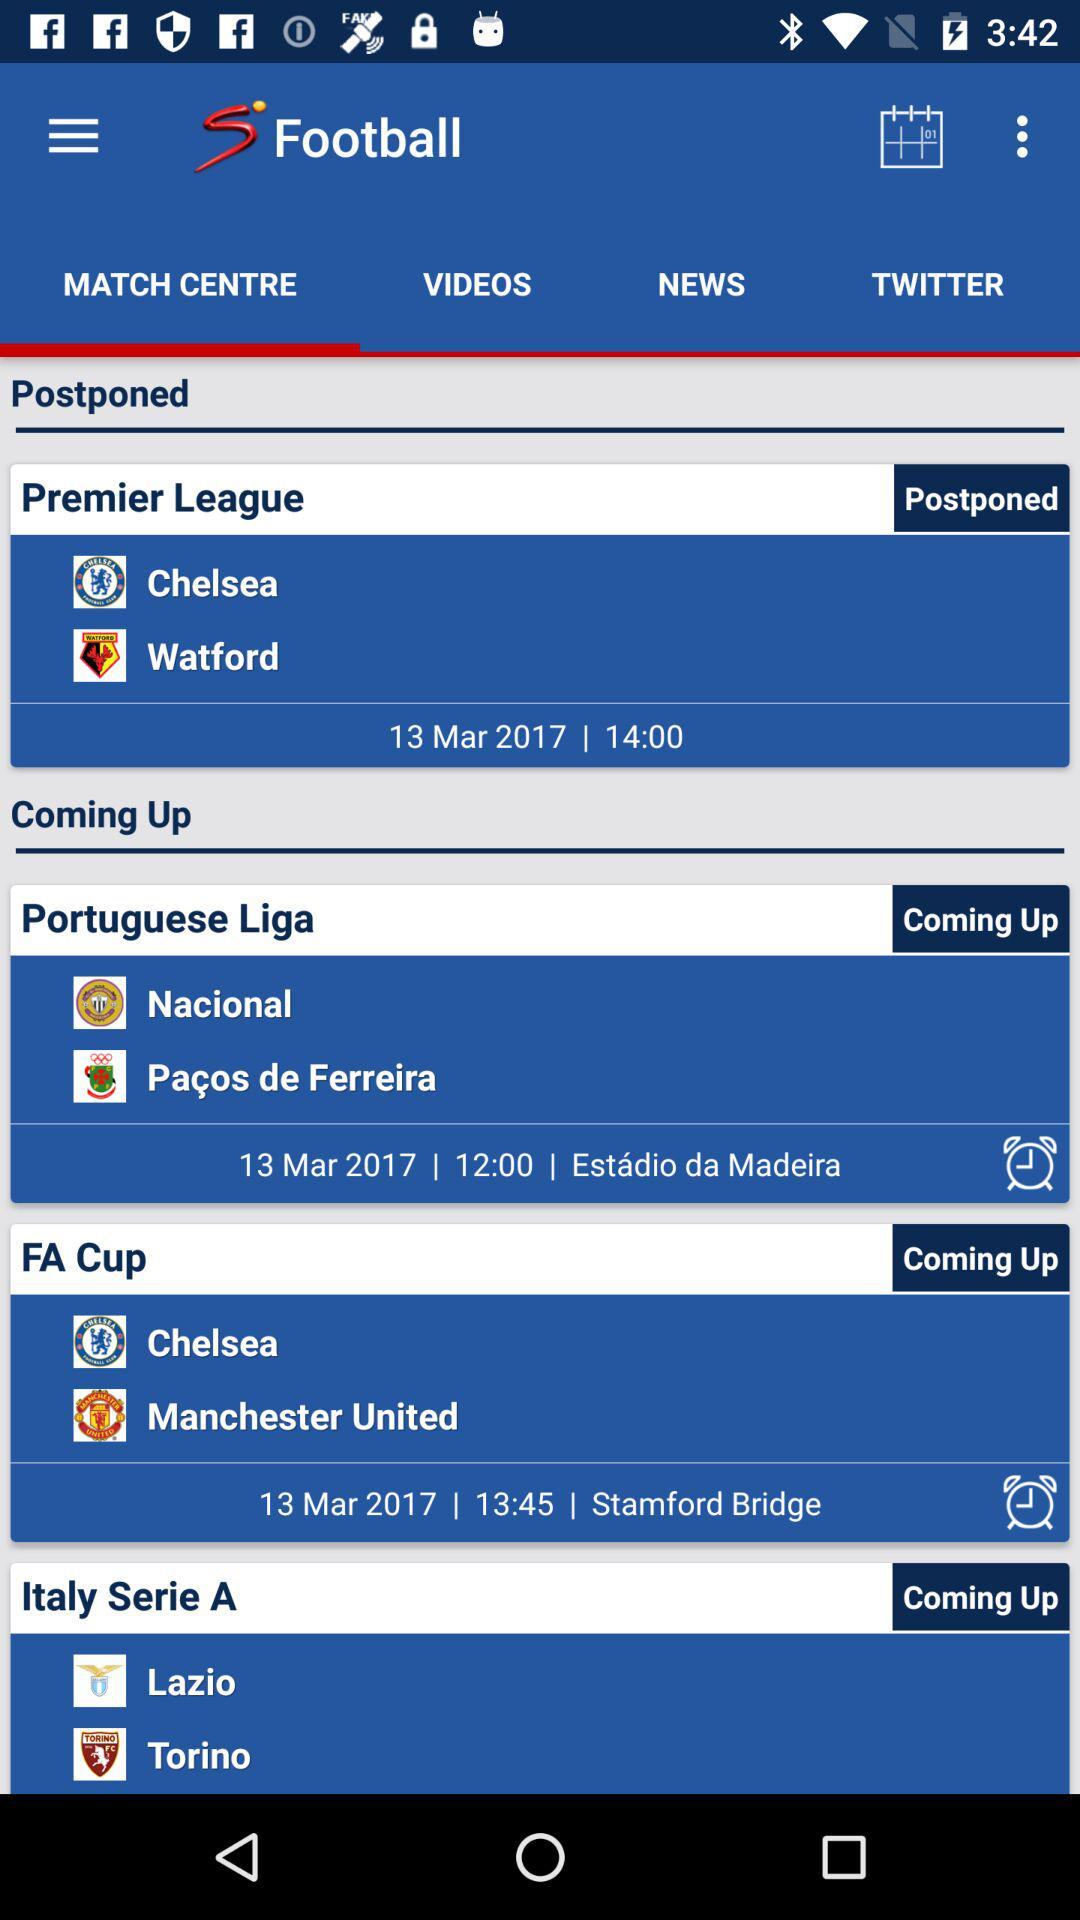How many matches are coming up?
Answer the question using a single word or phrase. 3 